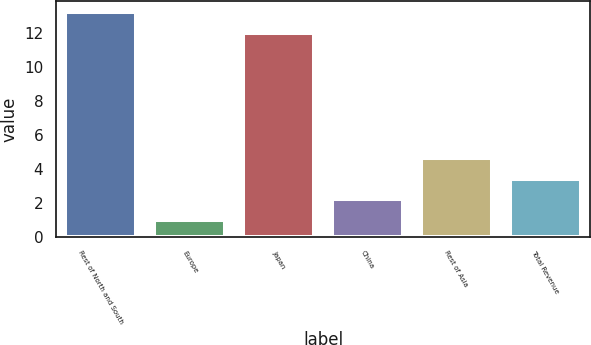<chart> <loc_0><loc_0><loc_500><loc_500><bar_chart><fcel>Rest of North and South<fcel>Europe<fcel>Japan<fcel>China<fcel>Rest of Asia<fcel>Total Revenue<nl><fcel>13.2<fcel>1<fcel>12<fcel>2.2<fcel>4.6<fcel>3.4<nl></chart> 